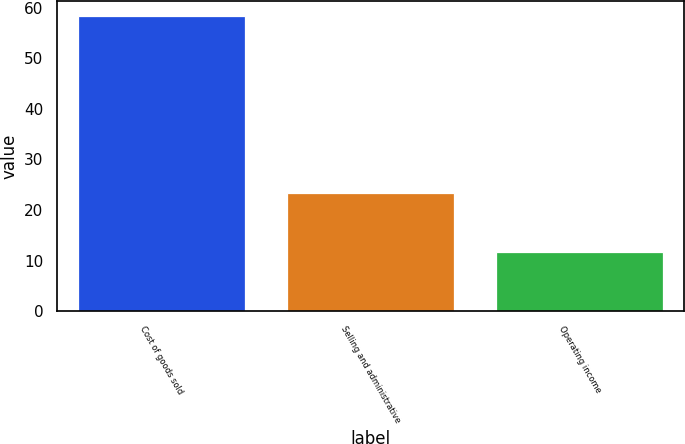Convert chart. <chart><loc_0><loc_0><loc_500><loc_500><bar_chart><fcel>Cost of goods sold<fcel>Selling and administrative<fcel>Operating income<nl><fcel>58.4<fcel>23.3<fcel>11.6<nl></chart> 